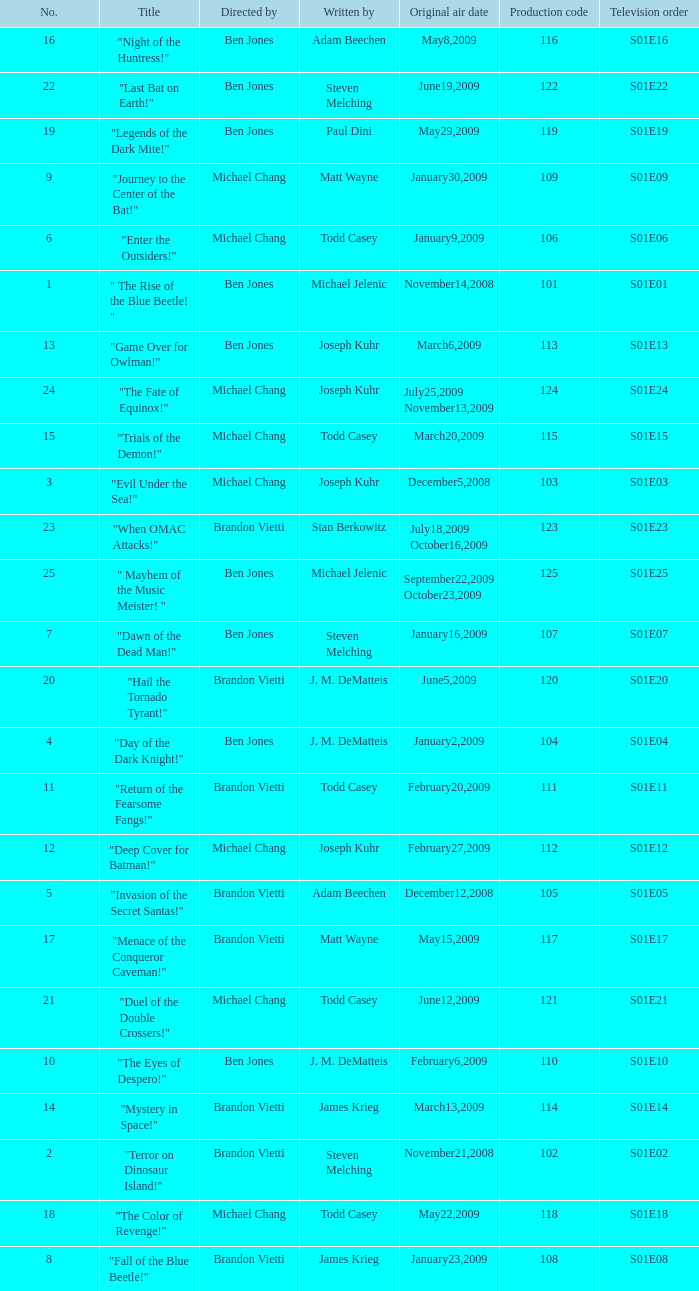What is the the television order of "deep cover for batman!" S01E12. 